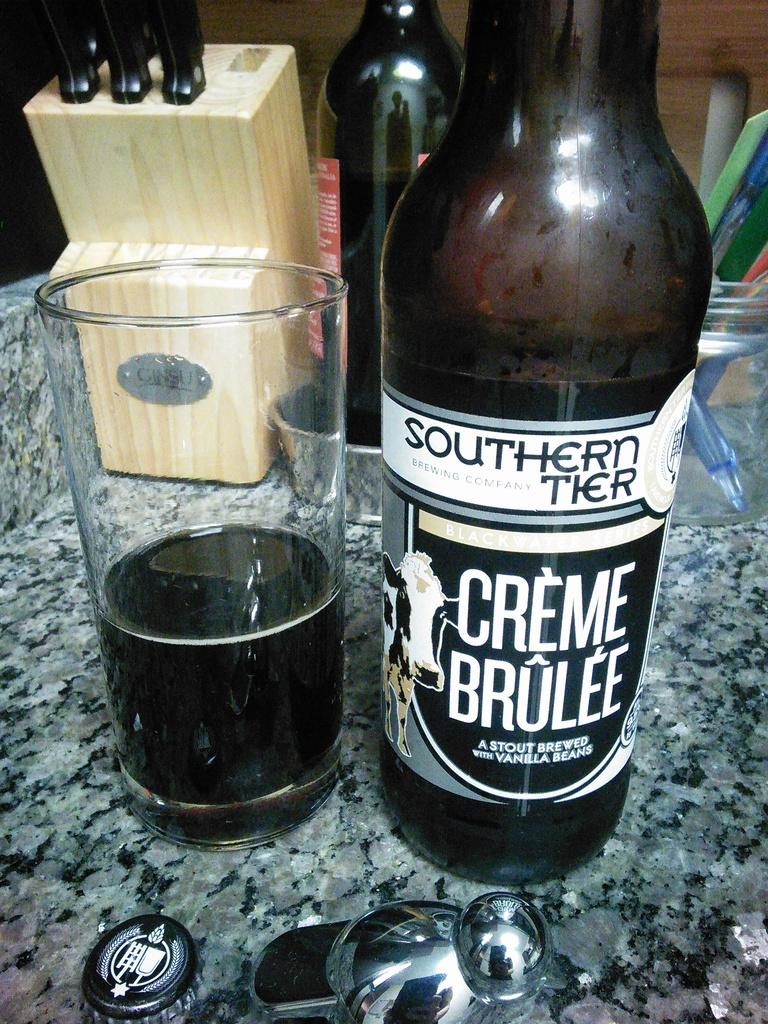Provide a one-sentence caption for the provided image. Bottle of Creme Brulee next to a cup of beer. 